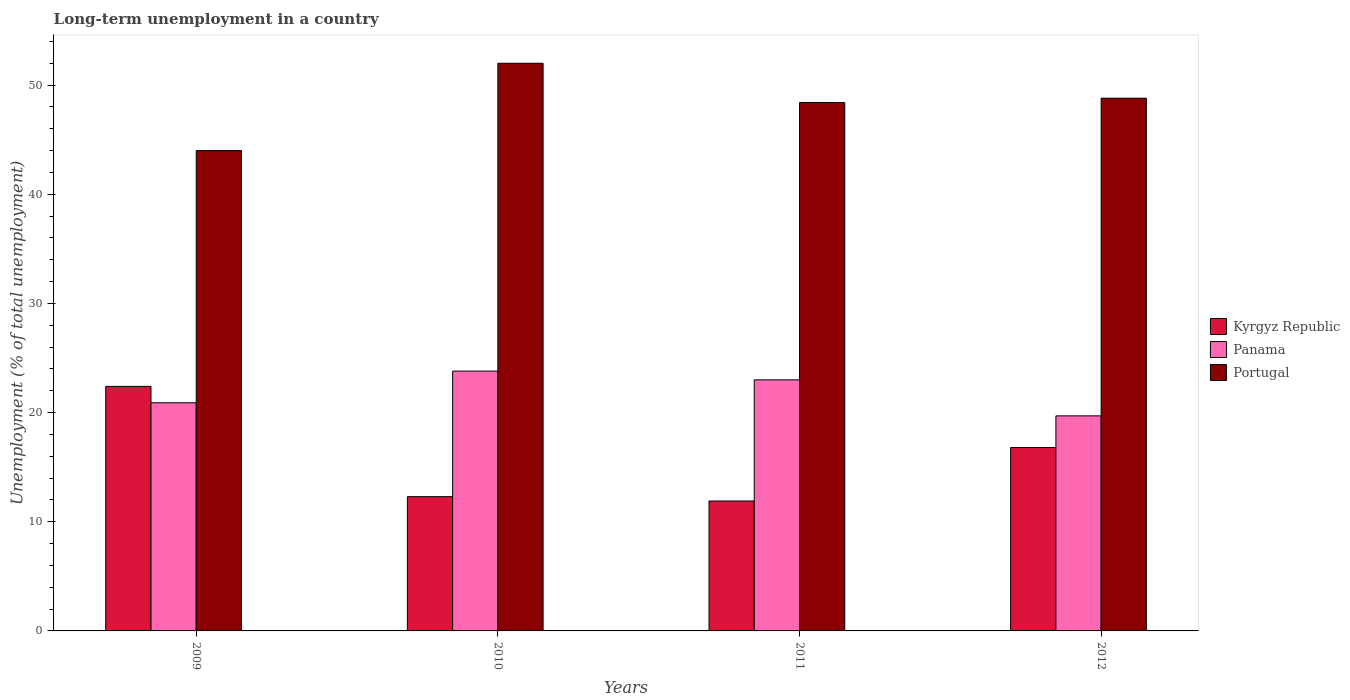Are the number of bars per tick equal to the number of legend labels?
Give a very brief answer. Yes. Are the number of bars on each tick of the X-axis equal?
Ensure brevity in your answer.  Yes. How many bars are there on the 3rd tick from the left?
Make the answer very short. 3. What is the label of the 2nd group of bars from the left?
Your response must be concise. 2010. In how many cases, is the number of bars for a given year not equal to the number of legend labels?
Your answer should be very brief. 0. Across all years, what is the maximum percentage of long-term unemployed population in Panama?
Your answer should be compact. 23.8. Across all years, what is the minimum percentage of long-term unemployed population in Panama?
Ensure brevity in your answer.  19.7. In which year was the percentage of long-term unemployed population in Kyrgyz Republic maximum?
Give a very brief answer. 2009. In which year was the percentage of long-term unemployed population in Panama minimum?
Your answer should be compact. 2012. What is the total percentage of long-term unemployed population in Kyrgyz Republic in the graph?
Keep it short and to the point. 63.4. What is the difference between the percentage of long-term unemployed population in Portugal in 2010 and that in 2012?
Offer a terse response. 3.2. What is the difference between the percentage of long-term unemployed population in Kyrgyz Republic in 2011 and the percentage of long-term unemployed population in Panama in 2009?
Make the answer very short. -9. What is the average percentage of long-term unemployed population in Panama per year?
Provide a succinct answer. 21.85. In the year 2012, what is the difference between the percentage of long-term unemployed population in Kyrgyz Republic and percentage of long-term unemployed population in Portugal?
Give a very brief answer. -32. In how many years, is the percentage of long-term unemployed population in Panama greater than 30 %?
Offer a terse response. 0. What is the ratio of the percentage of long-term unemployed population in Panama in 2009 to that in 2011?
Make the answer very short. 0.91. What is the difference between the highest and the second highest percentage of long-term unemployed population in Panama?
Provide a succinct answer. 0.8. What is the difference between the highest and the lowest percentage of long-term unemployed population in Portugal?
Your response must be concise. 8. In how many years, is the percentage of long-term unemployed population in Kyrgyz Republic greater than the average percentage of long-term unemployed population in Kyrgyz Republic taken over all years?
Your answer should be compact. 2. Is the sum of the percentage of long-term unemployed population in Kyrgyz Republic in 2010 and 2012 greater than the maximum percentage of long-term unemployed population in Panama across all years?
Your response must be concise. Yes. What does the 2nd bar from the left in 2011 represents?
Your response must be concise. Panama. What does the 3rd bar from the right in 2011 represents?
Provide a short and direct response. Kyrgyz Republic. Is it the case that in every year, the sum of the percentage of long-term unemployed population in Panama and percentage of long-term unemployed population in Kyrgyz Republic is greater than the percentage of long-term unemployed population in Portugal?
Make the answer very short. No. Are all the bars in the graph horizontal?
Your response must be concise. No. How many years are there in the graph?
Your answer should be very brief. 4. What is the difference between two consecutive major ticks on the Y-axis?
Your answer should be very brief. 10. Does the graph contain grids?
Your response must be concise. No. How many legend labels are there?
Keep it short and to the point. 3. How are the legend labels stacked?
Offer a terse response. Vertical. What is the title of the graph?
Your response must be concise. Long-term unemployment in a country. What is the label or title of the Y-axis?
Offer a terse response. Unemployment (% of total unemployment). What is the Unemployment (% of total unemployment) of Kyrgyz Republic in 2009?
Offer a terse response. 22.4. What is the Unemployment (% of total unemployment) of Panama in 2009?
Provide a succinct answer. 20.9. What is the Unemployment (% of total unemployment) of Kyrgyz Republic in 2010?
Offer a very short reply. 12.3. What is the Unemployment (% of total unemployment) of Panama in 2010?
Ensure brevity in your answer.  23.8. What is the Unemployment (% of total unemployment) in Kyrgyz Republic in 2011?
Offer a very short reply. 11.9. What is the Unemployment (% of total unemployment) in Panama in 2011?
Provide a short and direct response. 23. What is the Unemployment (% of total unemployment) in Portugal in 2011?
Offer a very short reply. 48.4. What is the Unemployment (% of total unemployment) in Kyrgyz Republic in 2012?
Give a very brief answer. 16.8. What is the Unemployment (% of total unemployment) in Panama in 2012?
Provide a short and direct response. 19.7. What is the Unemployment (% of total unemployment) of Portugal in 2012?
Provide a short and direct response. 48.8. Across all years, what is the maximum Unemployment (% of total unemployment) in Kyrgyz Republic?
Ensure brevity in your answer.  22.4. Across all years, what is the maximum Unemployment (% of total unemployment) of Panama?
Offer a terse response. 23.8. Across all years, what is the maximum Unemployment (% of total unemployment) in Portugal?
Your answer should be very brief. 52. Across all years, what is the minimum Unemployment (% of total unemployment) in Kyrgyz Republic?
Provide a succinct answer. 11.9. Across all years, what is the minimum Unemployment (% of total unemployment) of Panama?
Give a very brief answer. 19.7. Across all years, what is the minimum Unemployment (% of total unemployment) of Portugal?
Provide a short and direct response. 44. What is the total Unemployment (% of total unemployment) in Kyrgyz Republic in the graph?
Give a very brief answer. 63.4. What is the total Unemployment (% of total unemployment) in Panama in the graph?
Make the answer very short. 87.4. What is the total Unemployment (% of total unemployment) of Portugal in the graph?
Your response must be concise. 193.2. What is the difference between the Unemployment (% of total unemployment) of Kyrgyz Republic in 2009 and that in 2010?
Provide a short and direct response. 10.1. What is the difference between the Unemployment (% of total unemployment) of Portugal in 2009 and that in 2010?
Your answer should be compact. -8. What is the difference between the Unemployment (% of total unemployment) in Panama in 2009 and that in 2011?
Give a very brief answer. -2.1. What is the difference between the Unemployment (% of total unemployment) in Portugal in 2009 and that in 2011?
Provide a short and direct response. -4.4. What is the difference between the Unemployment (% of total unemployment) in Panama in 2009 and that in 2012?
Your answer should be compact. 1.2. What is the difference between the Unemployment (% of total unemployment) of Portugal in 2009 and that in 2012?
Your answer should be very brief. -4.8. What is the difference between the Unemployment (% of total unemployment) of Kyrgyz Republic in 2009 and the Unemployment (% of total unemployment) of Portugal in 2010?
Your answer should be very brief. -29.6. What is the difference between the Unemployment (% of total unemployment) of Panama in 2009 and the Unemployment (% of total unemployment) of Portugal in 2010?
Offer a very short reply. -31.1. What is the difference between the Unemployment (% of total unemployment) of Kyrgyz Republic in 2009 and the Unemployment (% of total unemployment) of Panama in 2011?
Offer a terse response. -0.6. What is the difference between the Unemployment (% of total unemployment) of Panama in 2009 and the Unemployment (% of total unemployment) of Portugal in 2011?
Keep it short and to the point. -27.5. What is the difference between the Unemployment (% of total unemployment) of Kyrgyz Republic in 2009 and the Unemployment (% of total unemployment) of Portugal in 2012?
Offer a terse response. -26.4. What is the difference between the Unemployment (% of total unemployment) of Panama in 2009 and the Unemployment (% of total unemployment) of Portugal in 2012?
Your response must be concise. -27.9. What is the difference between the Unemployment (% of total unemployment) of Kyrgyz Republic in 2010 and the Unemployment (% of total unemployment) of Panama in 2011?
Your response must be concise. -10.7. What is the difference between the Unemployment (% of total unemployment) of Kyrgyz Republic in 2010 and the Unemployment (% of total unemployment) of Portugal in 2011?
Offer a terse response. -36.1. What is the difference between the Unemployment (% of total unemployment) of Panama in 2010 and the Unemployment (% of total unemployment) of Portugal in 2011?
Provide a short and direct response. -24.6. What is the difference between the Unemployment (% of total unemployment) in Kyrgyz Republic in 2010 and the Unemployment (% of total unemployment) in Portugal in 2012?
Your response must be concise. -36.5. What is the difference between the Unemployment (% of total unemployment) of Panama in 2010 and the Unemployment (% of total unemployment) of Portugal in 2012?
Provide a short and direct response. -25. What is the difference between the Unemployment (% of total unemployment) in Kyrgyz Republic in 2011 and the Unemployment (% of total unemployment) in Panama in 2012?
Your answer should be compact. -7.8. What is the difference between the Unemployment (% of total unemployment) of Kyrgyz Republic in 2011 and the Unemployment (% of total unemployment) of Portugal in 2012?
Your answer should be very brief. -36.9. What is the difference between the Unemployment (% of total unemployment) of Panama in 2011 and the Unemployment (% of total unemployment) of Portugal in 2012?
Your response must be concise. -25.8. What is the average Unemployment (% of total unemployment) of Kyrgyz Republic per year?
Offer a very short reply. 15.85. What is the average Unemployment (% of total unemployment) of Panama per year?
Offer a terse response. 21.85. What is the average Unemployment (% of total unemployment) in Portugal per year?
Make the answer very short. 48.3. In the year 2009, what is the difference between the Unemployment (% of total unemployment) of Kyrgyz Republic and Unemployment (% of total unemployment) of Panama?
Make the answer very short. 1.5. In the year 2009, what is the difference between the Unemployment (% of total unemployment) of Kyrgyz Republic and Unemployment (% of total unemployment) of Portugal?
Make the answer very short. -21.6. In the year 2009, what is the difference between the Unemployment (% of total unemployment) in Panama and Unemployment (% of total unemployment) in Portugal?
Offer a very short reply. -23.1. In the year 2010, what is the difference between the Unemployment (% of total unemployment) in Kyrgyz Republic and Unemployment (% of total unemployment) in Portugal?
Provide a short and direct response. -39.7. In the year 2010, what is the difference between the Unemployment (% of total unemployment) in Panama and Unemployment (% of total unemployment) in Portugal?
Make the answer very short. -28.2. In the year 2011, what is the difference between the Unemployment (% of total unemployment) of Kyrgyz Republic and Unemployment (% of total unemployment) of Portugal?
Your answer should be very brief. -36.5. In the year 2011, what is the difference between the Unemployment (% of total unemployment) in Panama and Unemployment (% of total unemployment) in Portugal?
Provide a short and direct response. -25.4. In the year 2012, what is the difference between the Unemployment (% of total unemployment) in Kyrgyz Republic and Unemployment (% of total unemployment) in Panama?
Offer a very short reply. -2.9. In the year 2012, what is the difference between the Unemployment (% of total unemployment) in Kyrgyz Republic and Unemployment (% of total unemployment) in Portugal?
Provide a short and direct response. -32. In the year 2012, what is the difference between the Unemployment (% of total unemployment) of Panama and Unemployment (% of total unemployment) of Portugal?
Offer a terse response. -29.1. What is the ratio of the Unemployment (% of total unemployment) of Kyrgyz Republic in 2009 to that in 2010?
Your answer should be compact. 1.82. What is the ratio of the Unemployment (% of total unemployment) in Panama in 2009 to that in 2010?
Offer a terse response. 0.88. What is the ratio of the Unemployment (% of total unemployment) in Portugal in 2009 to that in 2010?
Give a very brief answer. 0.85. What is the ratio of the Unemployment (% of total unemployment) in Kyrgyz Republic in 2009 to that in 2011?
Make the answer very short. 1.88. What is the ratio of the Unemployment (% of total unemployment) in Panama in 2009 to that in 2011?
Give a very brief answer. 0.91. What is the ratio of the Unemployment (% of total unemployment) in Portugal in 2009 to that in 2011?
Offer a terse response. 0.91. What is the ratio of the Unemployment (% of total unemployment) in Kyrgyz Republic in 2009 to that in 2012?
Your answer should be very brief. 1.33. What is the ratio of the Unemployment (% of total unemployment) in Panama in 2009 to that in 2012?
Your answer should be compact. 1.06. What is the ratio of the Unemployment (% of total unemployment) of Portugal in 2009 to that in 2012?
Give a very brief answer. 0.9. What is the ratio of the Unemployment (% of total unemployment) in Kyrgyz Republic in 2010 to that in 2011?
Your answer should be compact. 1.03. What is the ratio of the Unemployment (% of total unemployment) of Panama in 2010 to that in 2011?
Offer a very short reply. 1.03. What is the ratio of the Unemployment (% of total unemployment) of Portugal in 2010 to that in 2011?
Your answer should be compact. 1.07. What is the ratio of the Unemployment (% of total unemployment) of Kyrgyz Republic in 2010 to that in 2012?
Make the answer very short. 0.73. What is the ratio of the Unemployment (% of total unemployment) of Panama in 2010 to that in 2012?
Your answer should be very brief. 1.21. What is the ratio of the Unemployment (% of total unemployment) of Portugal in 2010 to that in 2012?
Your answer should be very brief. 1.07. What is the ratio of the Unemployment (% of total unemployment) in Kyrgyz Republic in 2011 to that in 2012?
Provide a succinct answer. 0.71. What is the ratio of the Unemployment (% of total unemployment) in Panama in 2011 to that in 2012?
Your answer should be compact. 1.17. What is the ratio of the Unemployment (% of total unemployment) in Portugal in 2011 to that in 2012?
Your answer should be compact. 0.99. What is the difference between the highest and the second highest Unemployment (% of total unemployment) of Kyrgyz Republic?
Provide a succinct answer. 5.6. What is the difference between the highest and the lowest Unemployment (% of total unemployment) of Kyrgyz Republic?
Your response must be concise. 10.5. What is the difference between the highest and the lowest Unemployment (% of total unemployment) of Panama?
Provide a short and direct response. 4.1. 